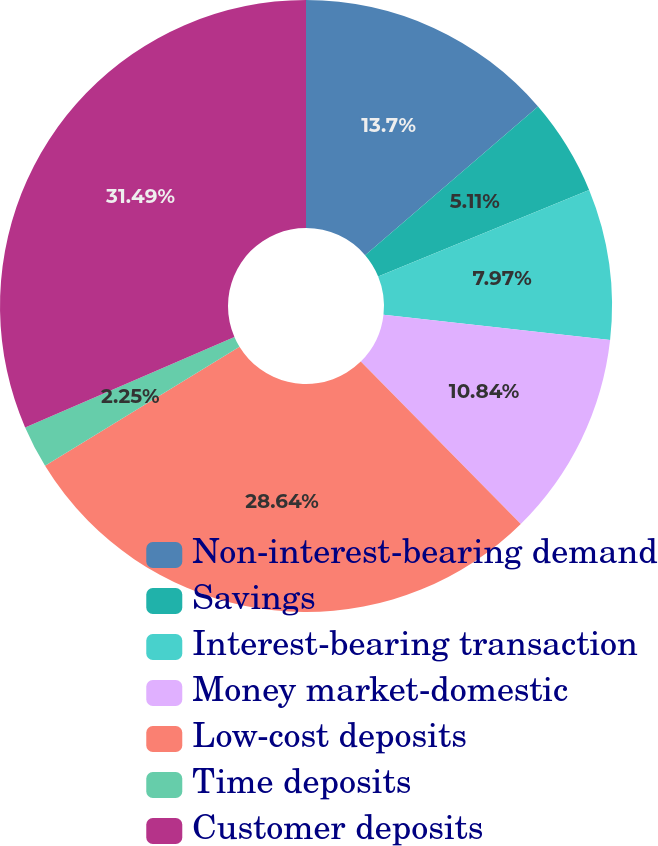Convert chart. <chart><loc_0><loc_0><loc_500><loc_500><pie_chart><fcel>Non-interest-bearing demand<fcel>Savings<fcel>Interest-bearing transaction<fcel>Money market-domestic<fcel>Low-cost deposits<fcel>Time deposits<fcel>Customer deposits<nl><fcel>13.7%<fcel>5.11%<fcel>7.97%<fcel>10.84%<fcel>28.64%<fcel>2.25%<fcel>31.5%<nl></chart> 